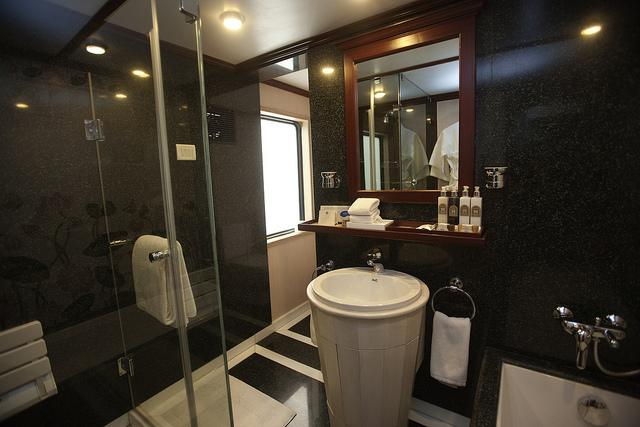What is most likely outside the doorway? bedroom 